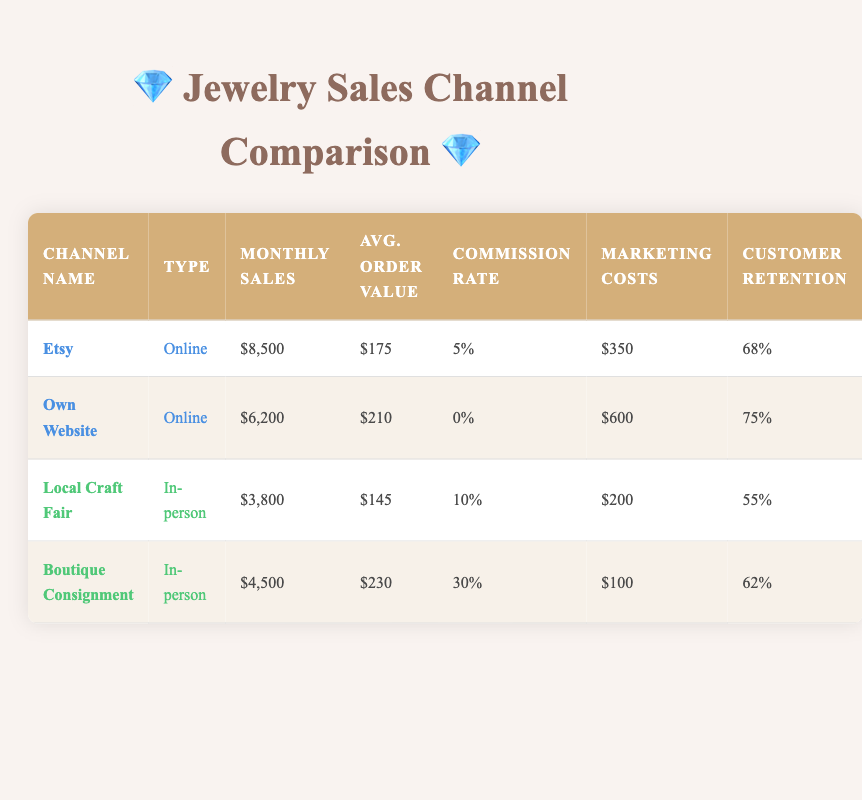What is the monthly sales for Etsy? According to the table, the row for Etsy shows a monthly sales figure of $8,500.
Answer: $8,500 Which sales channel has the highest average order value? By comparing the average order value for each channel: Etsy is $175, Own Website is $210, Local Craft Fair is $145, and Boutique Consignment is $230. The highest value is therefore from Boutique Consignment at $230.
Answer: $230 Is the commission rate for Own Website 0%? Looking at the Own Website row, it shows a commission rate of 0%, confirming that this is correct.
Answer: Yes What is the total monthly sales for both online channels? The monthly sales for online channels are Etsy ($8,500) and Own Website ($6,200). Adding these up gives $8,500 + $6,200 = $14,700.
Answer: $14,700 Does Boutique Consignment have a higher customer retention rate than Local Craft Fair? From the table, Boutique Consignment has a customer retention rate of 62%, while Local Craft Fair has a rate of 55%. Since 62% is greater than 55%, this statement is true.
Answer: Yes What is the average marketing cost for the online sales channels? The marketing costs for the online channels are $350 for Etsy and $600 for Own Website. Summing these gives $350 + $600 = $950. Then, to find the average, we divide by 2 channels: $950 / 2 = $475.
Answer: $475 Which in-person channel has the lowest monthly sales? The monthly sales for in-person channels are Local Craft Fair ($3,800) and Boutique Consignment ($4,500). Comparing these, Local Craft Fair has the lower sales number of $3,800.
Answer: Local Craft Fair How much more does market the Own Website spend on marketing compared to Local Craft Fair? The marketing cost for Own Website is $600, while for Local Craft Fair it is $200. The difference is calculated as $600 - $200 = $400.
Answer: $400 What percentage of the customer demographic for online sales channels is female? According to the data for online sales channels, the percentage of females is 78%.
Answer: 78% Is the average income level of online customers classified as upper-middle? The demographic data shows that online customers have an average income level labeled as "Upper-middle," confirming that the classification is accurate.
Answer: Yes 